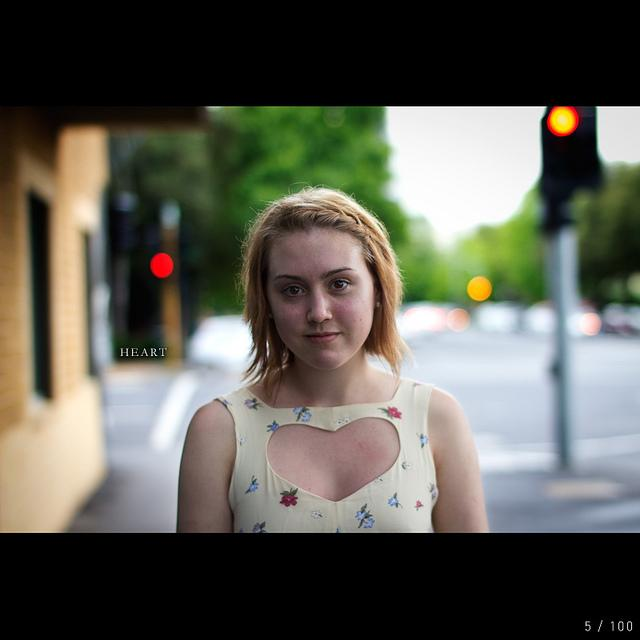What age group is this person in?

Choices:
A) 5-13
B) 35-50
C) 55-70
D) 18-30 18-30 